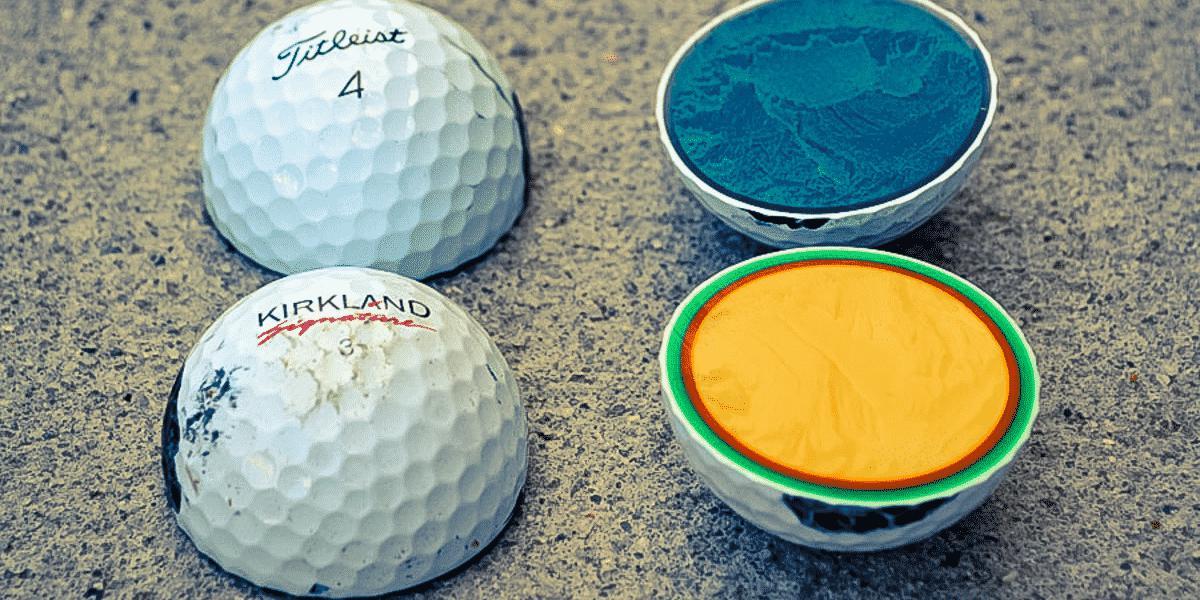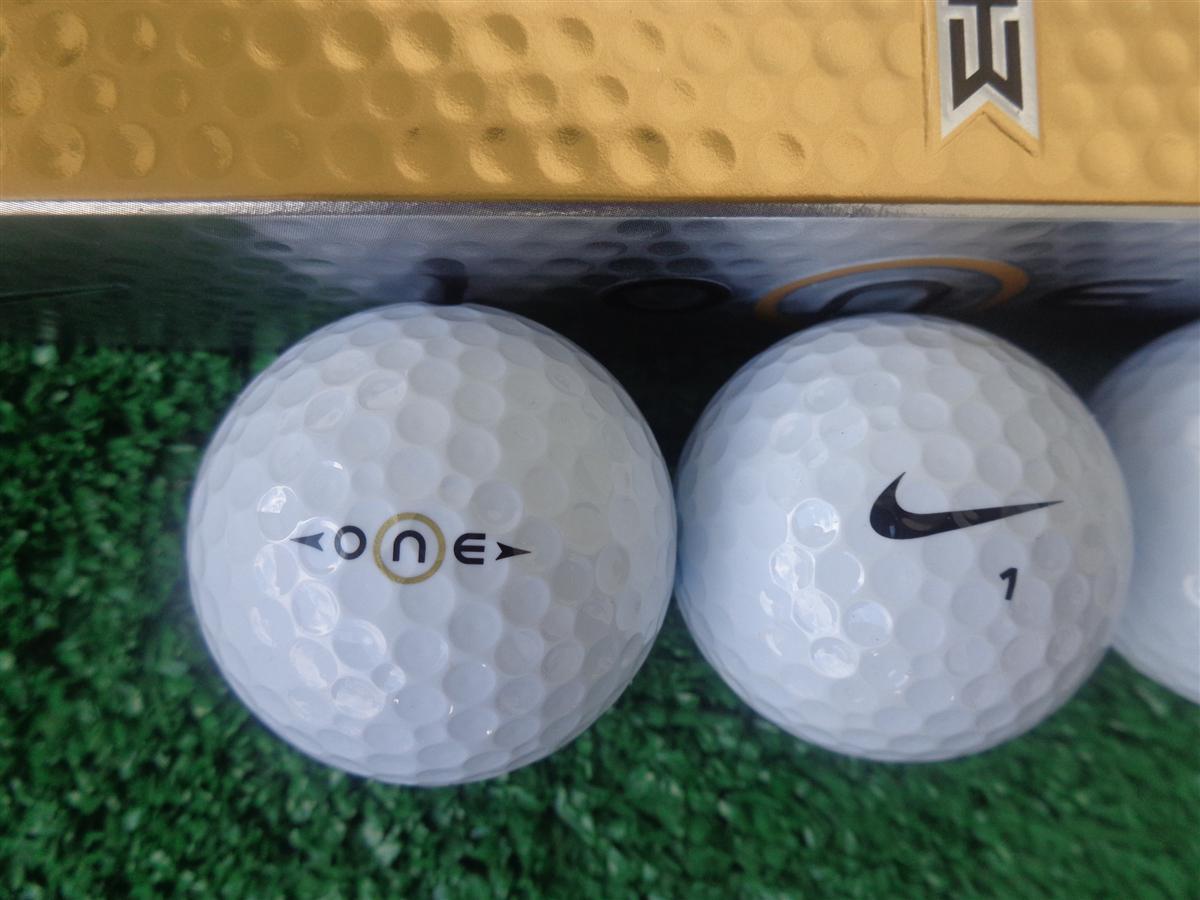The first image is the image on the left, the second image is the image on the right. For the images shown, is this caption "There are three golf balls in the left image and one in the right." true? Answer yes or no. No. The first image is the image on the left, the second image is the image on the right. For the images shown, is this caption "The left image features three white golf balls in a straight row under a silver box with gold trim." true? Answer yes or no. No. 